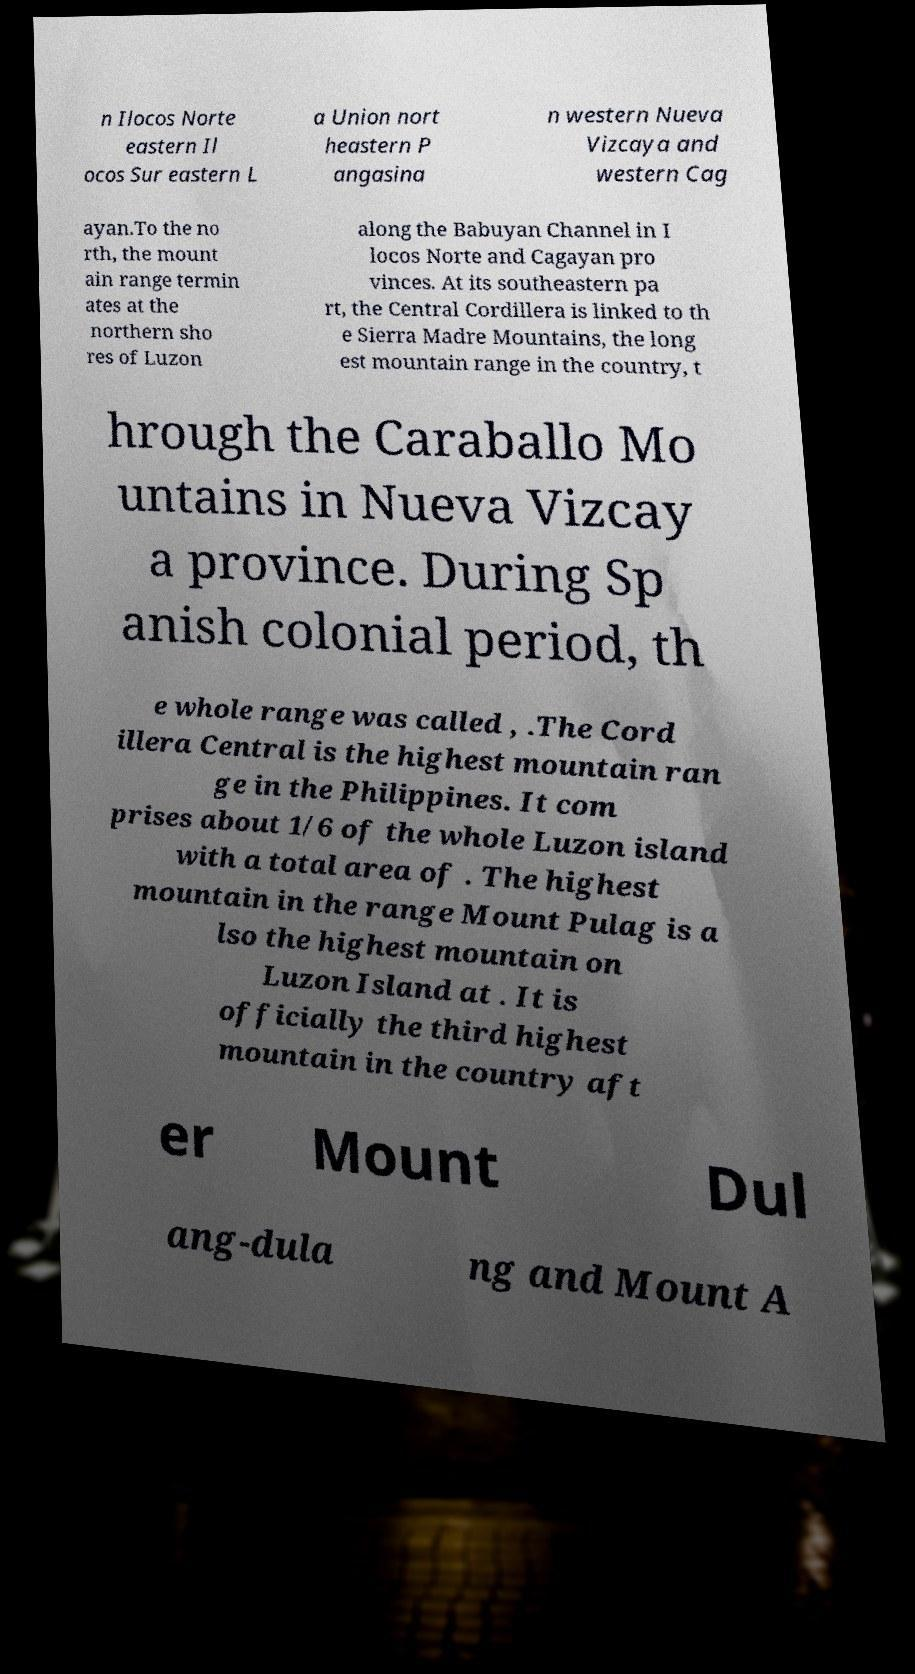There's text embedded in this image that I need extracted. Can you transcribe it verbatim? n Ilocos Norte eastern Il ocos Sur eastern L a Union nort heastern P angasina n western Nueva Vizcaya and western Cag ayan.To the no rth, the mount ain range termin ates at the northern sho res of Luzon along the Babuyan Channel in I locos Norte and Cagayan pro vinces. At its southeastern pa rt, the Central Cordillera is linked to th e Sierra Madre Mountains, the long est mountain range in the country, t hrough the Caraballo Mo untains in Nueva Vizcay a province. During Sp anish colonial period, th e whole range was called , .The Cord illera Central is the highest mountain ran ge in the Philippines. It com prises about 1/6 of the whole Luzon island with a total area of . The highest mountain in the range Mount Pulag is a lso the highest mountain on Luzon Island at . It is officially the third highest mountain in the country aft er Mount Dul ang-dula ng and Mount A 